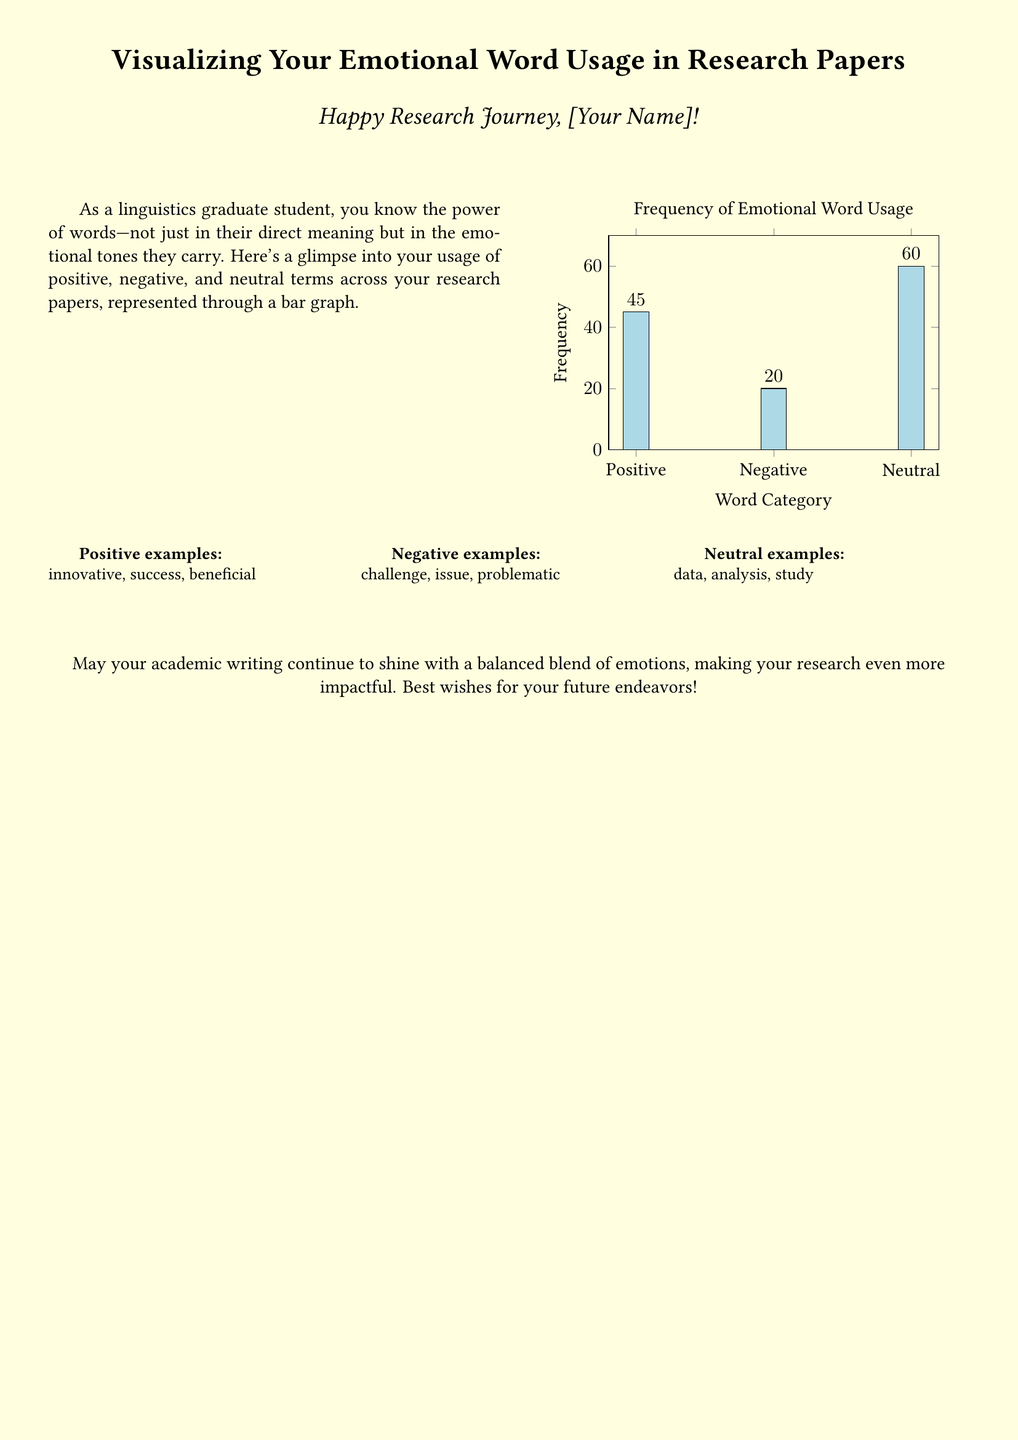What is the title of the graph? The title of the graph is provided at the top of the visual representation, highlighting its purpose.
Answer: Frequency of Emotional Word Usage How many positive terms are present in the graph? The graph displays the frequency of emotional word usage categorized into positive, negative, and neutral terms, with a specific value for positives.
Answer: 45 What is the frequency of negative terms? The negative terms' frequency is indicated as a specific value in the bar graph, representing the number of negative words used.
Answer: 20 Which category has the highest frequency? By comparing the values in the graph, one can determine which emotional category is the most frequently used in the research papers.
Answer: Neutral What is the color used for positive terms in the graph? The color representing the positive terms is specified in the graph's design, linking it visually to the usage of positive language.
Answer: Light blue How many categories of words are represented in the bar graph? The label on the x-axis indicates the different categories included in the analysis of emotional word usage.
Answer: 3 What type of card is this document classified as? The document is created to convey a message and visual analysis aspect, which aligns with a specific type of document intended for a personal touch.
Answer: Greeting card What is the purpose of this document? The document serves a unique role, combining academic analysis with personal encouragement, which can be summarized succinctly.
Answer: Visualizing emotional word usage 